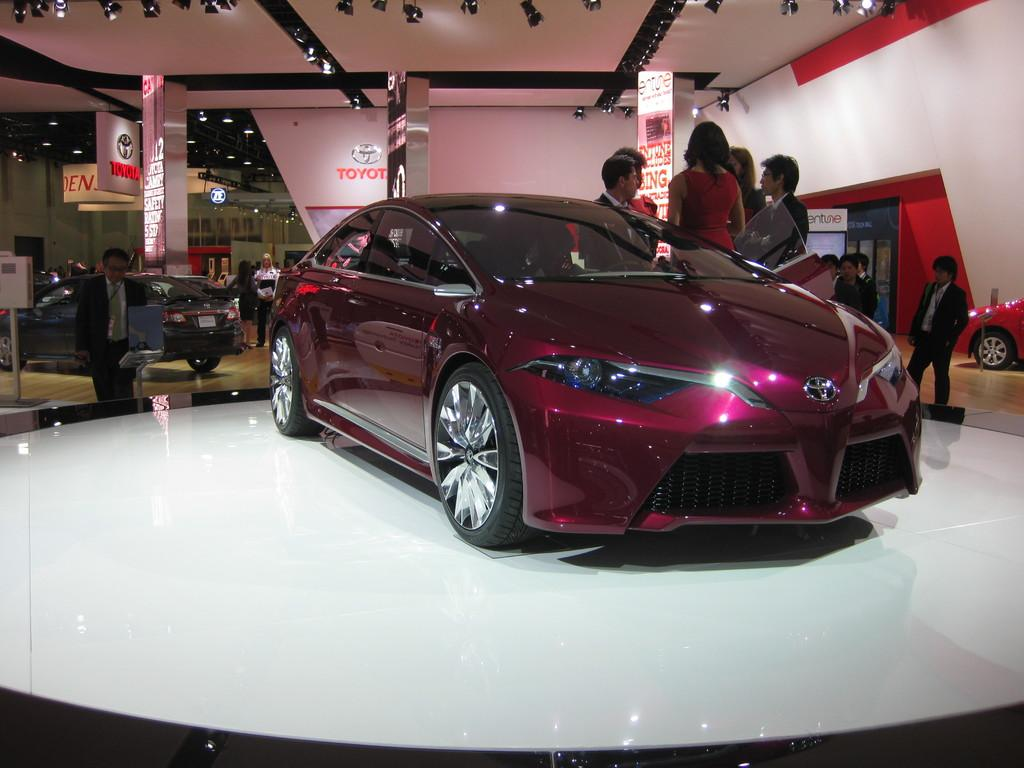What type of vehicles can be seen in the image? There are cars in the image. Can you describe the people in the image? There is a group of people in the image. What can be seen in the background of the image? There are hoardings, lights, and metal rods in the background of the image. What type of tomatoes are being used to create a square shape in the image? There are no tomatoes or square shapes present in the image. 